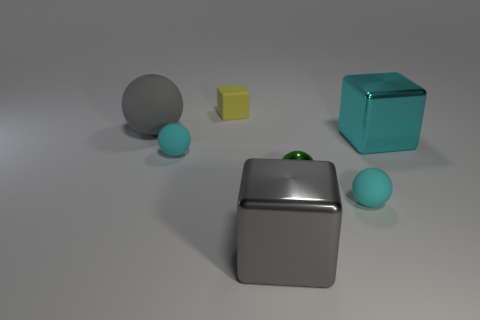Subtract all large metal blocks. How many blocks are left? 1 Subtract 1 blocks. How many blocks are left? 2 Subtract all gray cubes. How many cubes are left? 2 Add 1 big yellow matte objects. How many objects exist? 8 Subtract all red blocks. Subtract all gray cylinders. How many blocks are left? 3 Subtract all large red metallic blocks. Subtract all cyan matte spheres. How many objects are left? 5 Add 2 cubes. How many cubes are left? 5 Add 7 big green rubber cylinders. How many big green rubber cylinders exist? 7 Subtract 1 gray spheres. How many objects are left? 6 Subtract all blocks. How many objects are left? 4 